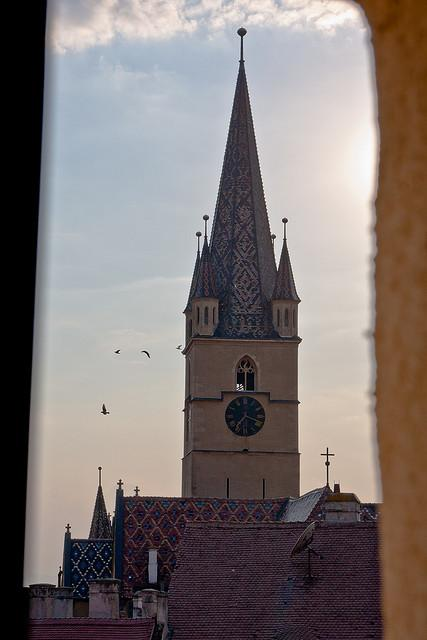How many towers are on the top of the clock tower with a black clock face? five 